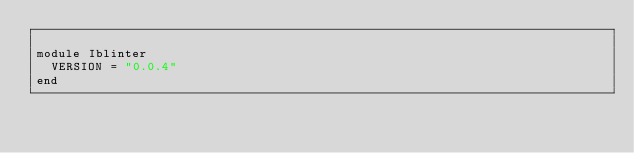<code> <loc_0><loc_0><loc_500><loc_500><_Ruby_>
module Iblinter
  VERSION = "0.0.4"
end
</code> 